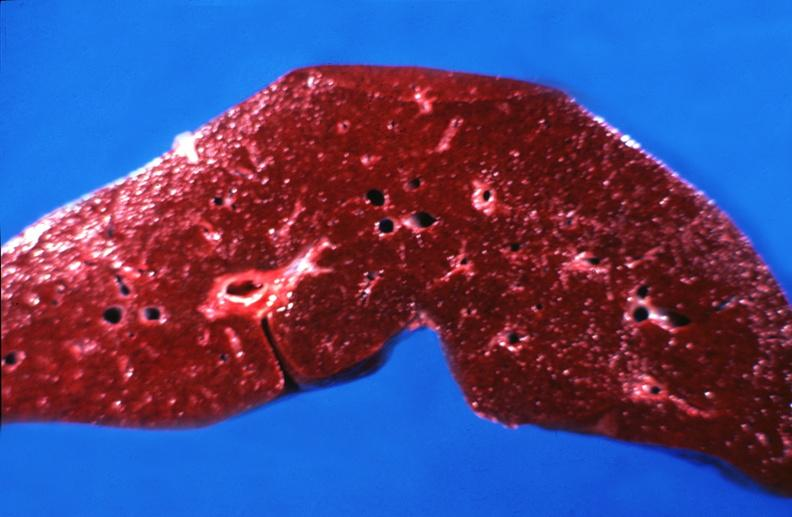what is present?
Answer the question using a single word or phrase. Liver 